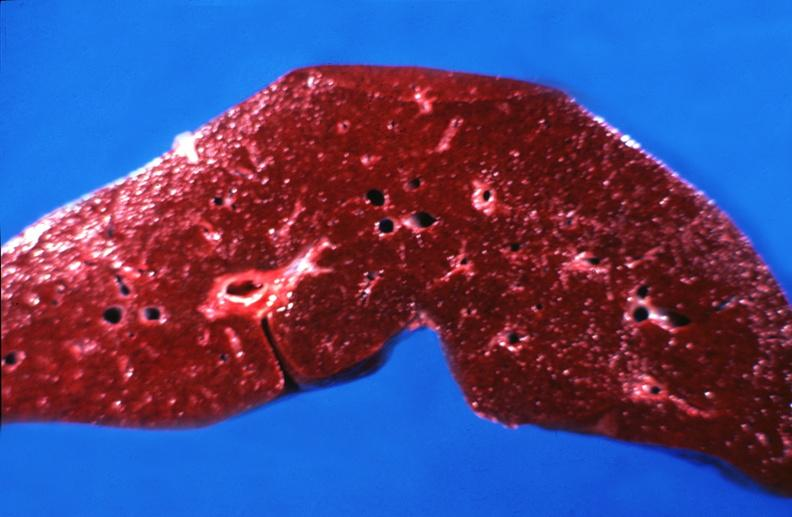what is present?
Answer the question using a single word or phrase. Liver 